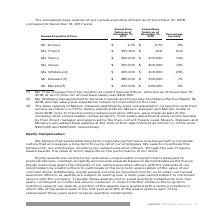From Square's financial document, What is the annual base salary of Ms. Henry in 2017 and 2018 respectively? The document shows two values: $350,000 and $400,000. From the document: "Ms. Henry $ 350,000 $ 400,000 14% Ms. Friar(1) $ 350,000 $ N/A N/A..." Also, What is the annual base salary of Mr. Murphy in 2017 and 2018 respectively? The document shows two values: $270,000 and $295,000. From the document: "Mr. Murphy(3) $ 270,000 $ 295,000 9% Mr. Murphy(3) $ 270,000 $ 295,000 9%..." Also, What is the annual base salary of Mr. Daswini in 2017 and 2018 respectively? The document shows two values: $280,000 and $300,000. From the document: "Mr. Daswani(3) $ 280,000 $ 300,000 7% Mr. Daswani(3) $ 280,000 $ 300,000 7%..." Also, can you calculate: What is the difference in annual base salary in 2017 between Mr. Daswani and Mr. Murphy? Based on the calculation: 280,000-270,000, the result is 10000. This is based on the information: "Mr. Murphy(3) $ 270,000 $ 295,000 9% Mr. Daswani(3) $ 280,000 $ 300,000 7%..." The key data points involved are: 270,000, 280,000. Additionally, Which Executive Officer has the largest percentage increase in their annual base salary from 2017 to 2018? According to the financial document, Ms. Whiteley. The relevant text states: "Ms. Whiteley(2) $ 325,000 $ 400,000 23%..." Also, can you calculate: What is the change in Ms Henry's annual base salary between 2017 and 2018? Based on the calculation: 400,000-350,000, the result is 50000. This is based on the information: "Ms. Henry $ 350,000 $ 400,000 14% Ms. Friar(1) $ 350,000 $ N/A N/A..." The key data points involved are: 350,000, 400,000. 